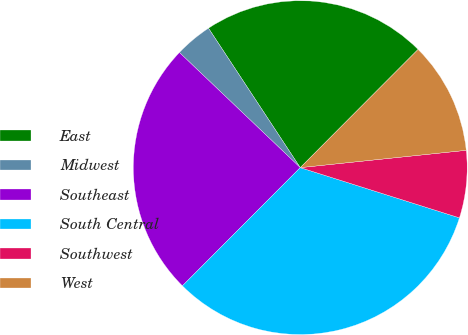Convert chart to OTSL. <chart><loc_0><loc_0><loc_500><loc_500><pie_chart><fcel>East<fcel>Midwest<fcel>Southeast<fcel>South Central<fcel>Southwest<fcel>West<nl><fcel>21.74%<fcel>3.62%<fcel>24.64%<fcel>32.61%<fcel>6.52%<fcel>10.87%<nl></chart> 